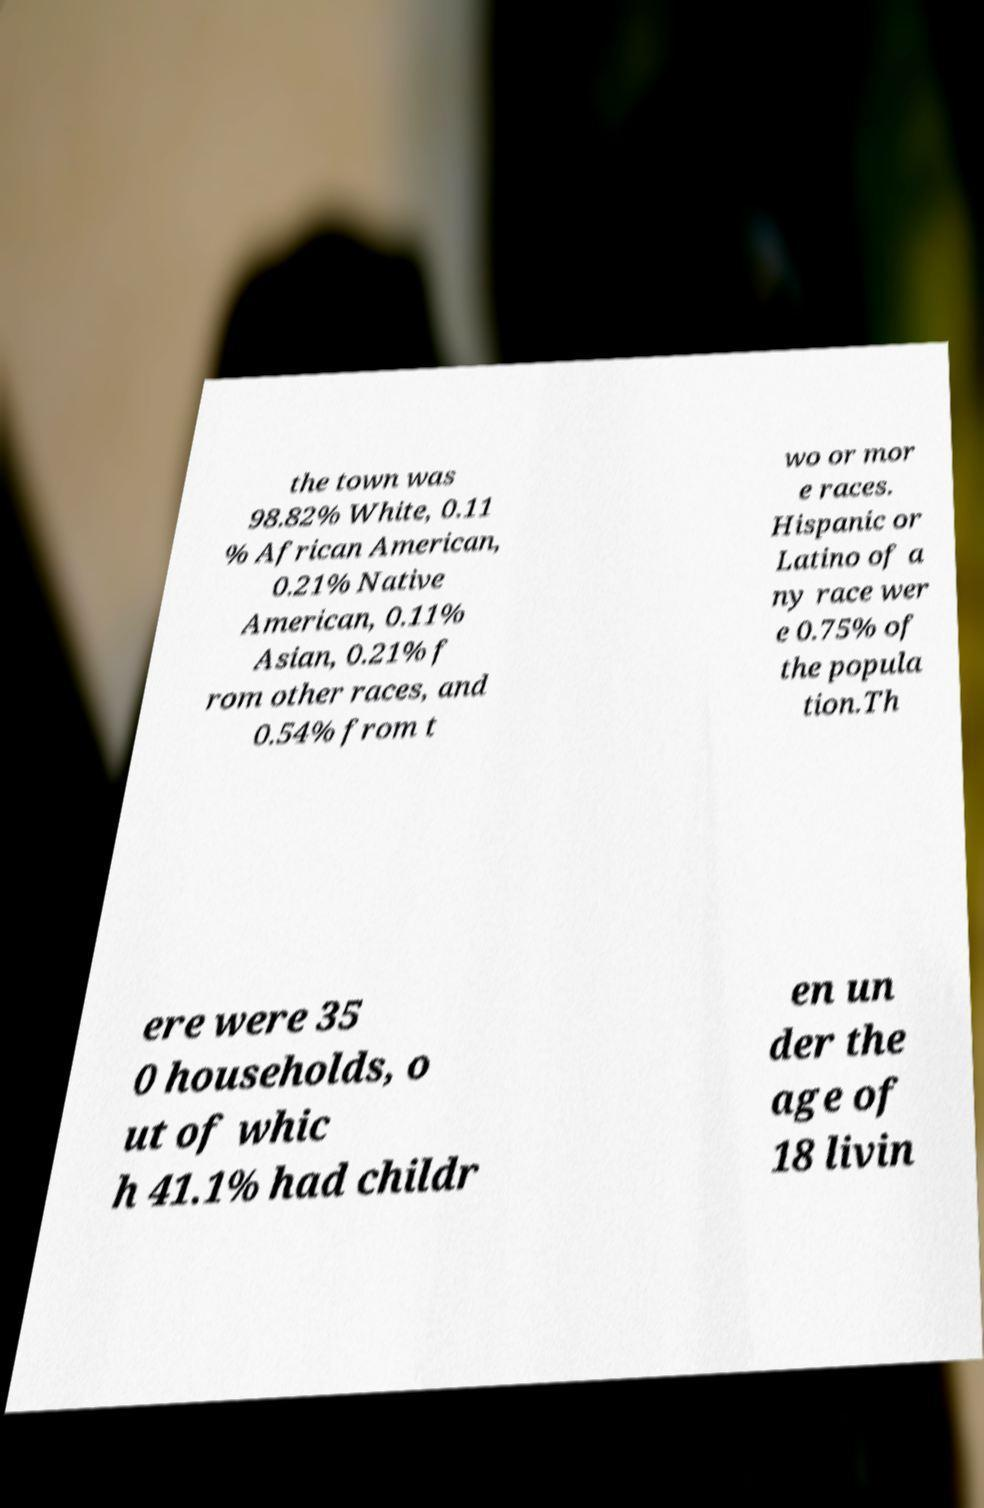I need the written content from this picture converted into text. Can you do that? the town was 98.82% White, 0.11 % African American, 0.21% Native American, 0.11% Asian, 0.21% f rom other races, and 0.54% from t wo or mor e races. Hispanic or Latino of a ny race wer e 0.75% of the popula tion.Th ere were 35 0 households, o ut of whic h 41.1% had childr en un der the age of 18 livin 